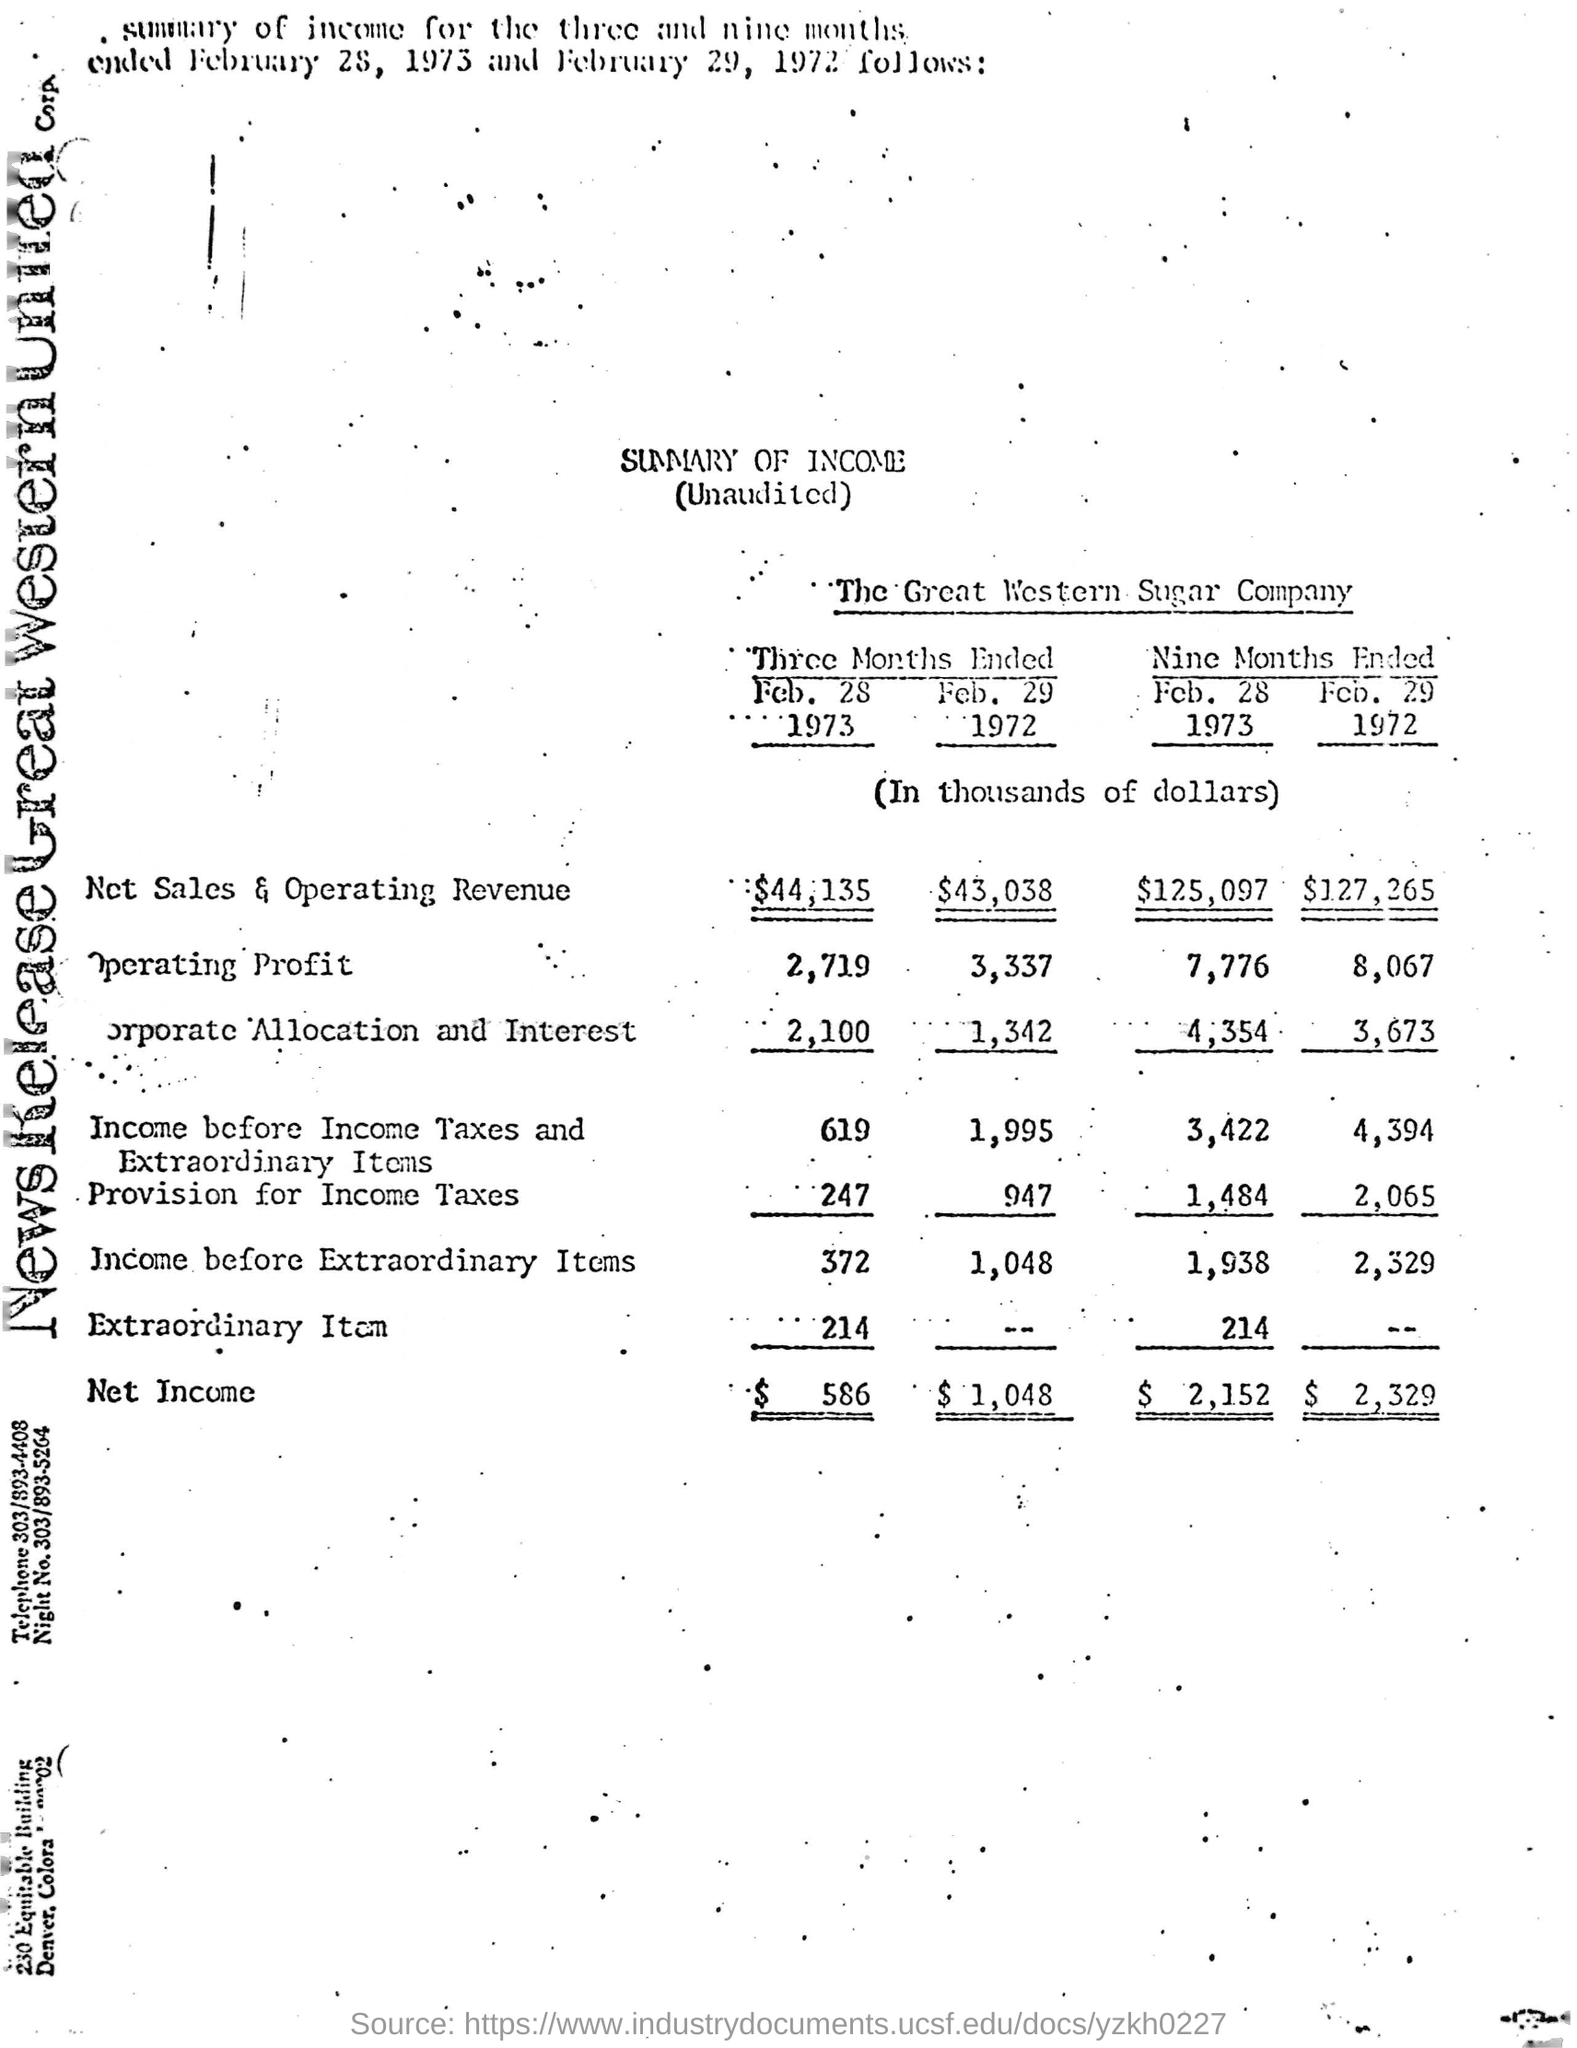What is the name of the company?
Your response must be concise. The Great Western Sugar Company. Figures/Amounts were in which currency?
Make the answer very short. Dollars. 